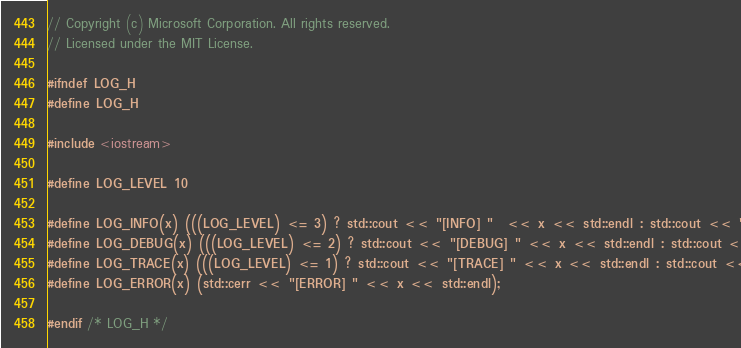<code> <loc_0><loc_0><loc_500><loc_500><_C_>// Copyright (c) Microsoft Corporation. All rights reserved.
// Licensed under the MIT License.

#ifndef LOG_H
#define LOG_H

#include <iostream>

#define LOG_LEVEL 10

#define LOG_INFO(x) (((LOG_LEVEL) <= 3) ? std::cout << "[INFO] "  << x << std::endl : std::cout << "")
#define LOG_DEBUG(x) (((LOG_LEVEL) <= 2) ? std::cout << "[DEBUG] " << x << std::endl : std::cout << "")
#define LOG_TRACE(x) (((LOG_LEVEL) <= 1) ? std::cout << "[TRACE] " << x << std::endl : std::cout << "")
#define LOG_ERROR(x) (std::cerr << "[ERROR] " << x << std::endl);

#endif /* LOG_H */
</code> 